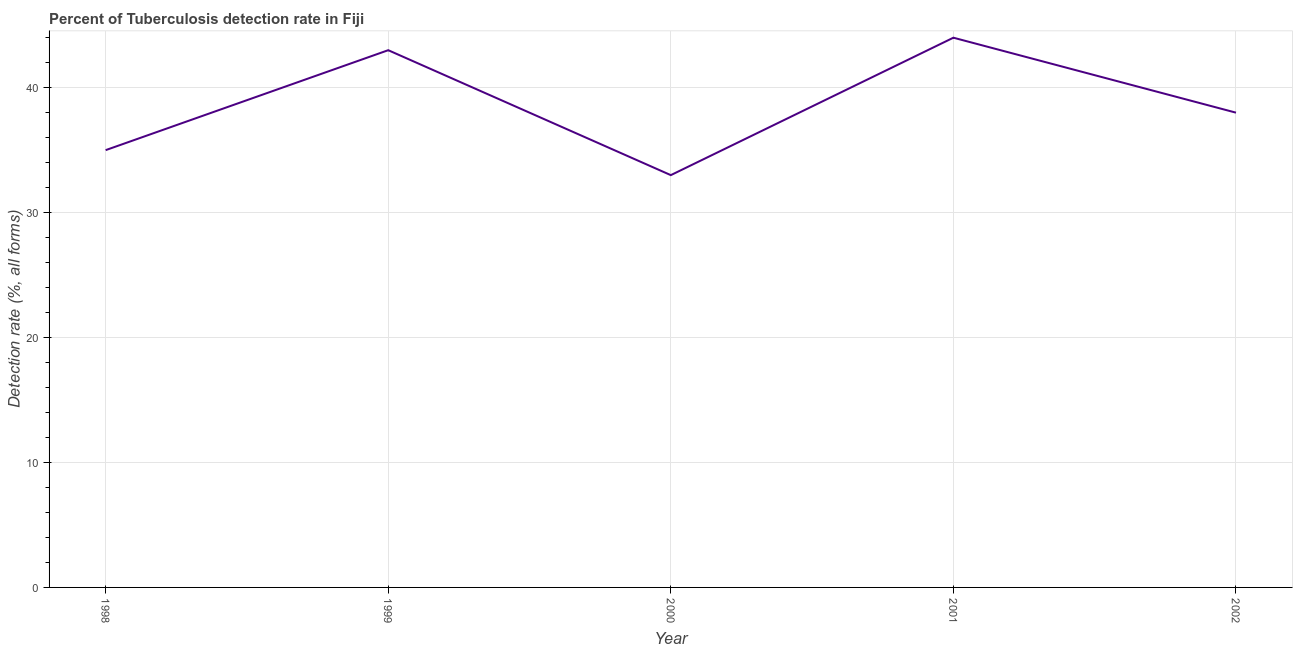What is the detection rate of tuberculosis in 2000?
Keep it short and to the point. 33. Across all years, what is the maximum detection rate of tuberculosis?
Your answer should be very brief. 44. Across all years, what is the minimum detection rate of tuberculosis?
Provide a succinct answer. 33. What is the sum of the detection rate of tuberculosis?
Offer a very short reply. 193. What is the difference between the detection rate of tuberculosis in 1998 and 2000?
Offer a very short reply. 2. What is the average detection rate of tuberculosis per year?
Offer a very short reply. 38.6. In how many years, is the detection rate of tuberculosis greater than 6 %?
Your answer should be compact. 5. What is the ratio of the detection rate of tuberculosis in 2000 to that in 2001?
Give a very brief answer. 0.75. Is the detection rate of tuberculosis in 1999 less than that in 2000?
Offer a very short reply. No. What is the difference between the highest and the second highest detection rate of tuberculosis?
Provide a short and direct response. 1. Is the sum of the detection rate of tuberculosis in 1999 and 2001 greater than the maximum detection rate of tuberculosis across all years?
Offer a very short reply. Yes. What is the difference between the highest and the lowest detection rate of tuberculosis?
Offer a terse response. 11. Does the detection rate of tuberculosis monotonically increase over the years?
Ensure brevity in your answer.  No. How many years are there in the graph?
Offer a very short reply. 5. What is the difference between two consecutive major ticks on the Y-axis?
Keep it short and to the point. 10. What is the title of the graph?
Keep it short and to the point. Percent of Tuberculosis detection rate in Fiji. What is the label or title of the Y-axis?
Offer a very short reply. Detection rate (%, all forms). What is the Detection rate (%, all forms) of 2000?
Provide a succinct answer. 33. What is the Detection rate (%, all forms) of 2002?
Offer a terse response. 38. What is the difference between the Detection rate (%, all forms) in 1998 and 1999?
Your response must be concise. -8. What is the difference between the Detection rate (%, all forms) in 1998 and 2000?
Give a very brief answer. 2. What is the difference between the Detection rate (%, all forms) in 1998 and 2001?
Give a very brief answer. -9. What is the difference between the Detection rate (%, all forms) in 1999 and 2000?
Offer a very short reply. 10. What is the ratio of the Detection rate (%, all forms) in 1998 to that in 1999?
Your response must be concise. 0.81. What is the ratio of the Detection rate (%, all forms) in 1998 to that in 2000?
Ensure brevity in your answer.  1.06. What is the ratio of the Detection rate (%, all forms) in 1998 to that in 2001?
Your answer should be compact. 0.8. What is the ratio of the Detection rate (%, all forms) in 1998 to that in 2002?
Give a very brief answer. 0.92. What is the ratio of the Detection rate (%, all forms) in 1999 to that in 2000?
Your response must be concise. 1.3. What is the ratio of the Detection rate (%, all forms) in 1999 to that in 2001?
Provide a succinct answer. 0.98. What is the ratio of the Detection rate (%, all forms) in 1999 to that in 2002?
Give a very brief answer. 1.13. What is the ratio of the Detection rate (%, all forms) in 2000 to that in 2001?
Your answer should be compact. 0.75. What is the ratio of the Detection rate (%, all forms) in 2000 to that in 2002?
Make the answer very short. 0.87. What is the ratio of the Detection rate (%, all forms) in 2001 to that in 2002?
Give a very brief answer. 1.16. 